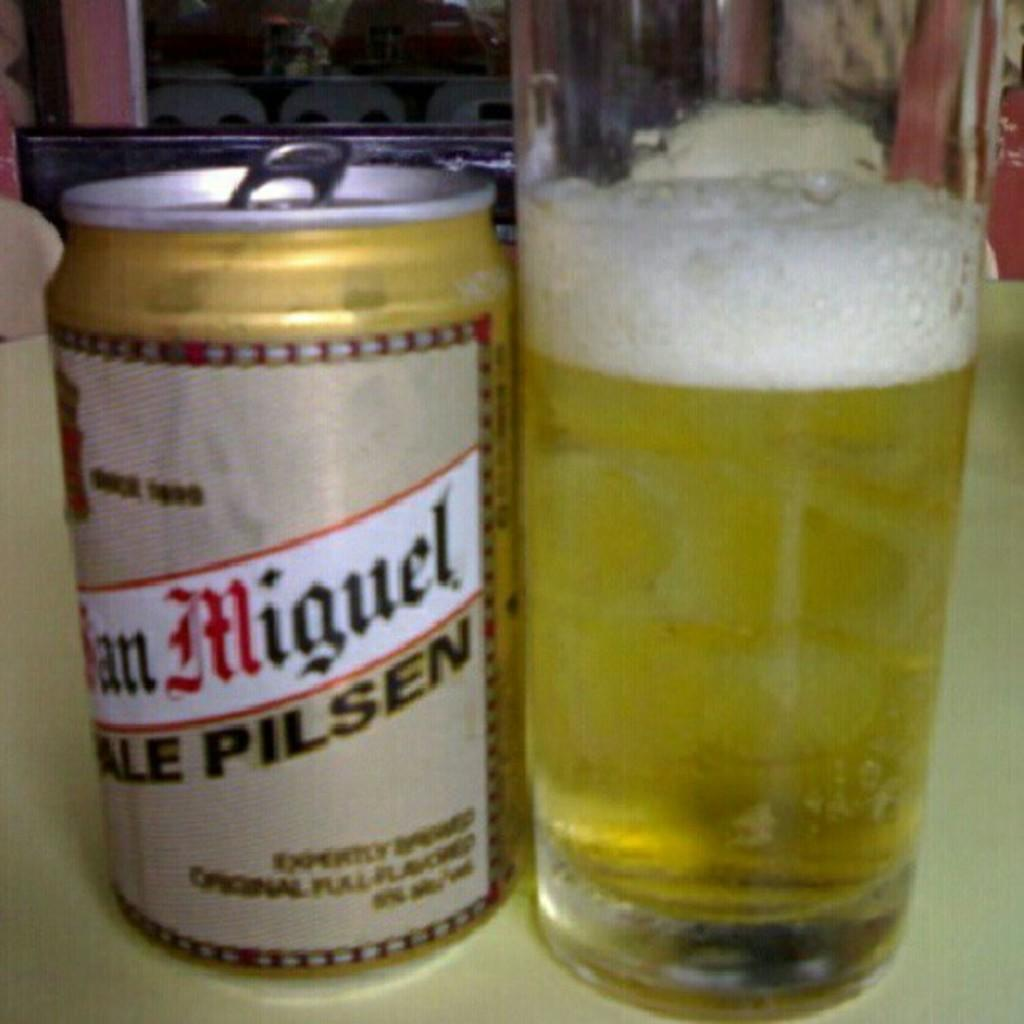<image>
Relay a brief, clear account of the picture shown. A can of San Miguel is next to a completely full glass. 